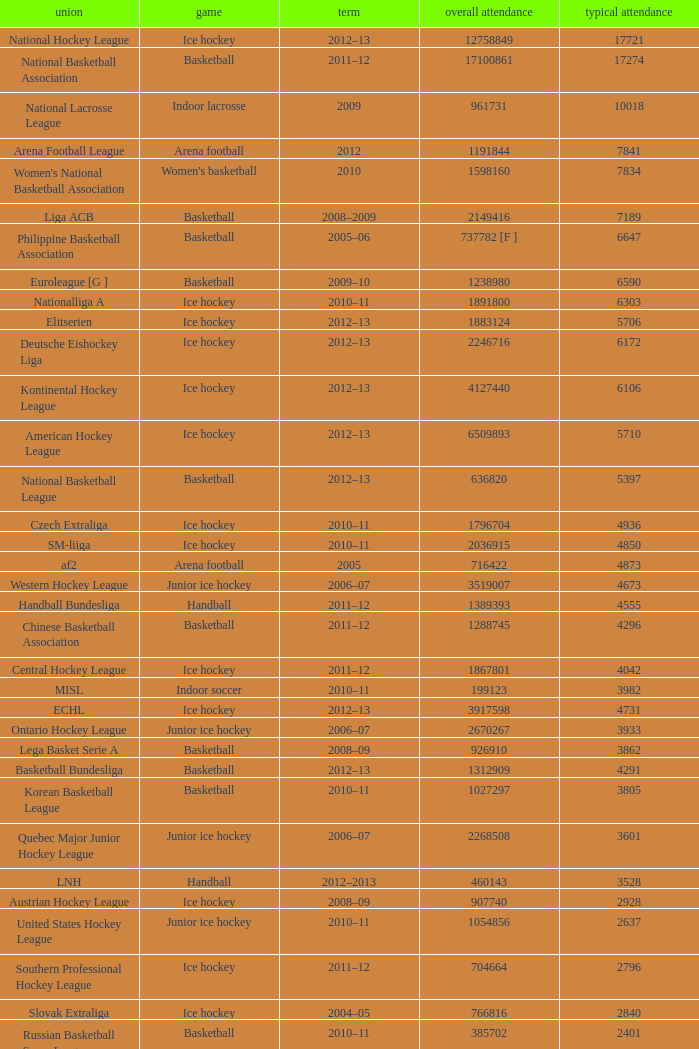What was the highest average attendance in the 2009 season? 10018.0. 